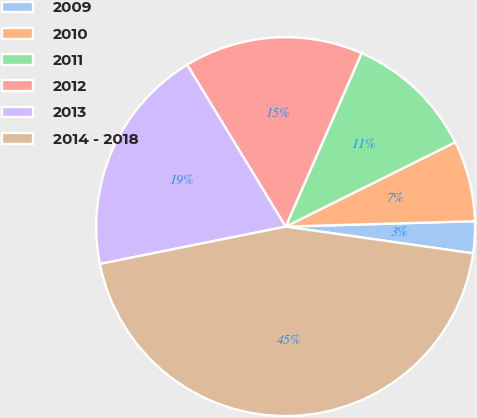<chart> <loc_0><loc_0><loc_500><loc_500><pie_chart><fcel>2009<fcel>2010<fcel>2011<fcel>2012<fcel>2013<fcel>2014 - 2018<nl><fcel>2.71%<fcel>6.89%<fcel>11.08%<fcel>15.27%<fcel>19.46%<fcel>44.59%<nl></chart> 